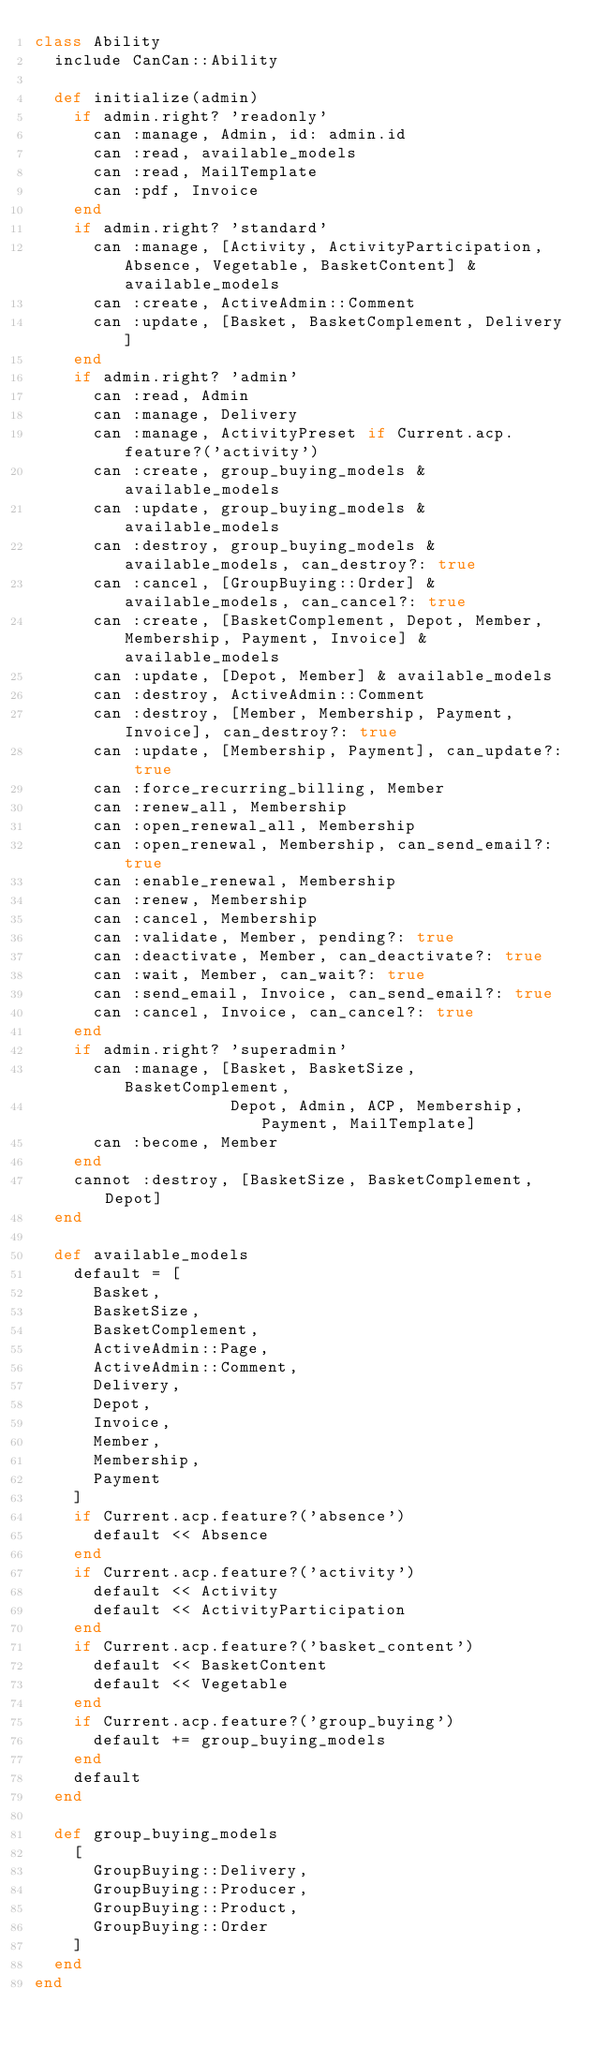<code> <loc_0><loc_0><loc_500><loc_500><_Ruby_>class Ability
  include CanCan::Ability

  def initialize(admin)
    if admin.right? 'readonly'
      can :manage, Admin, id: admin.id
      can :read, available_models
      can :read, MailTemplate
      can :pdf, Invoice
    end
    if admin.right? 'standard'
      can :manage, [Activity, ActivityParticipation, Absence, Vegetable, BasketContent] & available_models
      can :create, ActiveAdmin::Comment
      can :update, [Basket, BasketComplement, Delivery]
    end
    if admin.right? 'admin'
      can :read, Admin
      can :manage, Delivery
      can :manage, ActivityPreset if Current.acp.feature?('activity')
      can :create, group_buying_models & available_models
      can :update, group_buying_models & available_models
      can :destroy, group_buying_models & available_models, can_destroy?: true
      can :cancel, [GroupBuying::Order] & available_models, can_cancel?: true
      can :create, [BasketComplement, Depot, Member, Membership, Payment, Invoice] & available_models
      can :update, [Depot, Member] & available_models
      can :destroy, ActiveAdmin::Comment
      can :destroy, [Member, Membership, Payment, Invoice], can_destroy?: true
      can :update, [Membership, Payment], can_update?: true
      can :force_recurring_billing, Member
      can :renew_all, Membership
      can :open_renewal_all, Membership
      can :open_renewal, Membership, can_send_email?: true
      can :enable_renewal, Membership
      can :renew, Membership
      can :cancel, Membership
      can :validate, Member, pending?: true
      can :deactivate, Member, can_deactivate?: true
      can :wait, Member, can_wait?: true
      can :send_email, Invoice, can_send_email?: true
      can :cancel, Invoice, can_cancel?: true
    end
    if admin.right? 'superadmin'
      can :manage, [Basket, BasketSize, BasketComplement,
                    Depot, Admin, ACP, Membership, Payment, MailTemplate]
      can :become, Member
    end
    cannot :destroy, [BasketSize, BasketComplement, Depot]
  end

  def available_models
    default = [
      Basket,
      BasketSize,
      BasketComplement,
      ActiveAdmin::Page,
      ActiveAdmin::Comment,
      Delivery,
      Depot,
      Invoice,
      Member,
      Membership,
      Payment
    ]
    if Current.acp.feature?('absence')
      default << Absence
    end
    if Current.acp.feature?('activity')
      default << Activity
      default << ActivityParticipation
    end
    if Current.acp.feature?('basket_content')
      default << BasketContent
      default << Vegetable
    end
    if Current.acp.feature?('group_buying')
      default += group_buying_models
    end
    default
  end

  def group_buying_models
    [
      GroupBuying::Delivery,
      GroupBuying::Producer,
      GroupBuying::Product,
      GroupBuying::Order
    ]
  end
end
</code> 